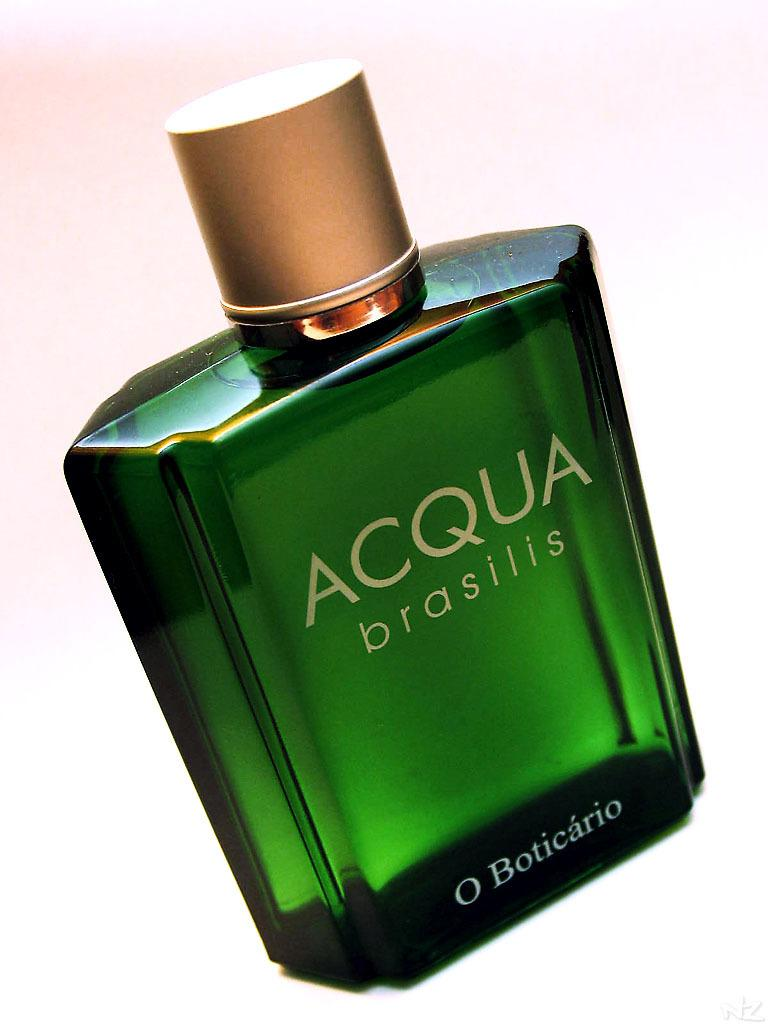<image>
Render a clear and concise summary of the photo. A green bottle of ACQUA looks attractive and costly 